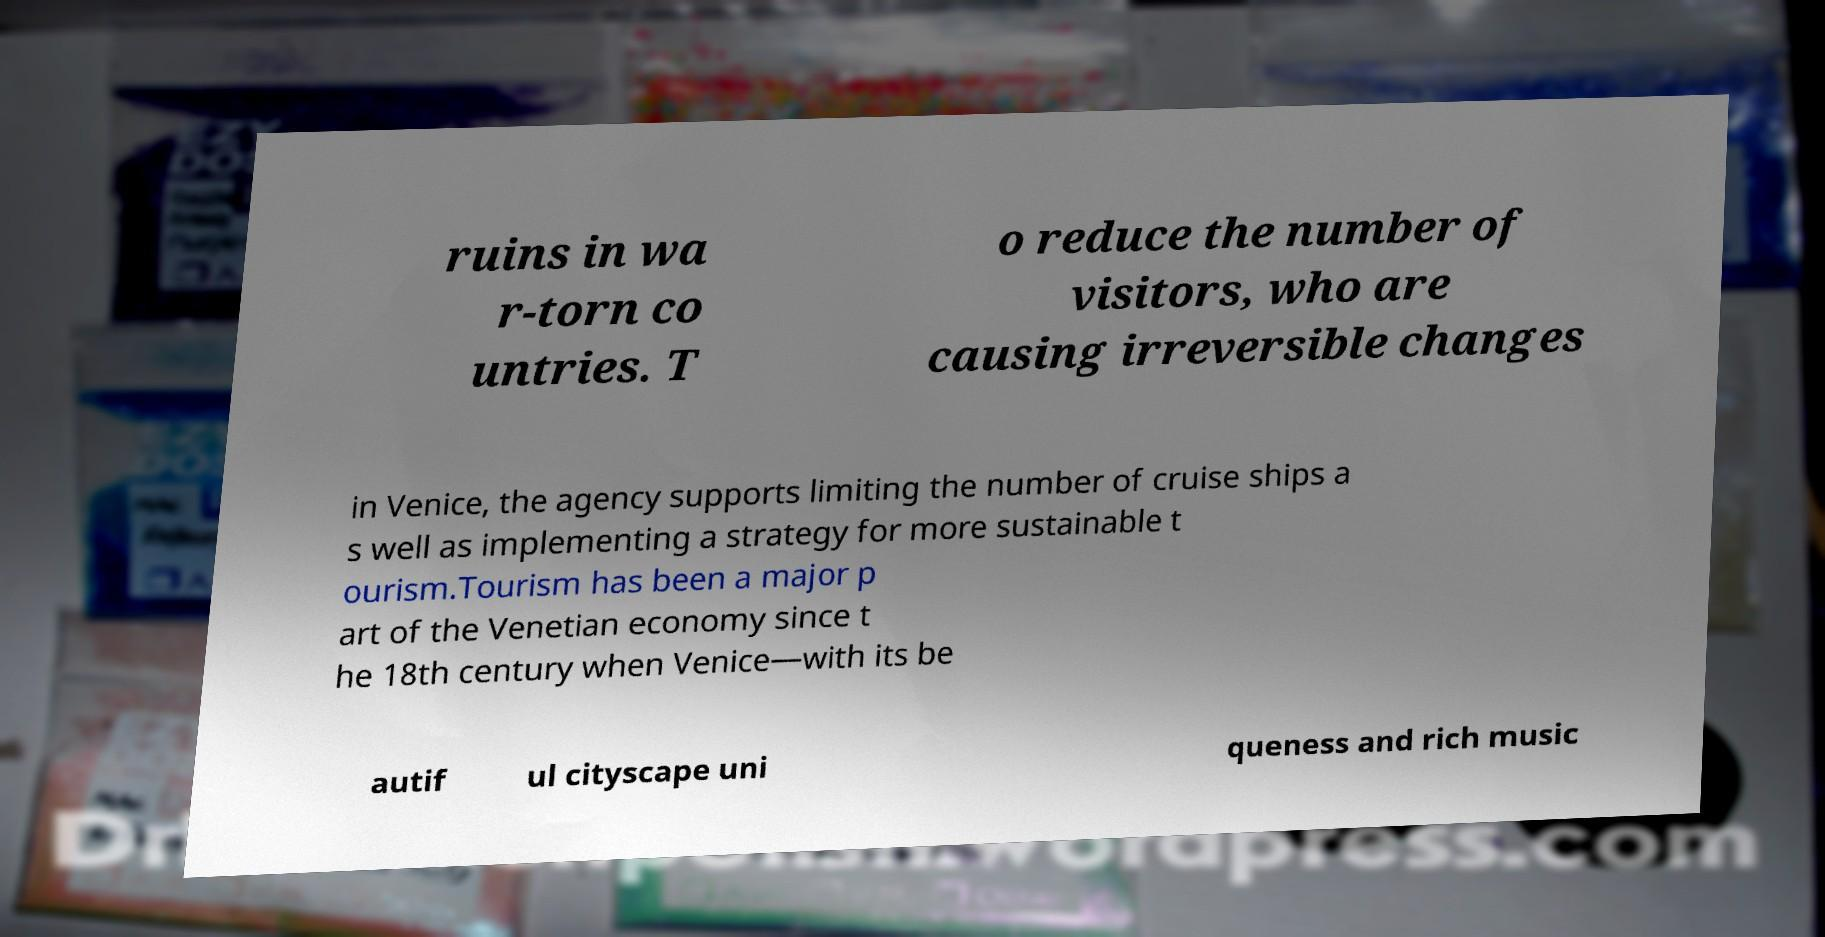Please identify and transcribe the text found in this image. ruins in wa r-torn co untries. T o reduce the number of visitors, who are causing irreversible changes in Venice, the agency supports limiting the number of cruise ships a s well as implementing a strategy for more sustainable t ourism.Tourism has been a major p art of the Venetian economy since t he 18th century when Venice—with its be autif ul cityscape uni queness and rich music 